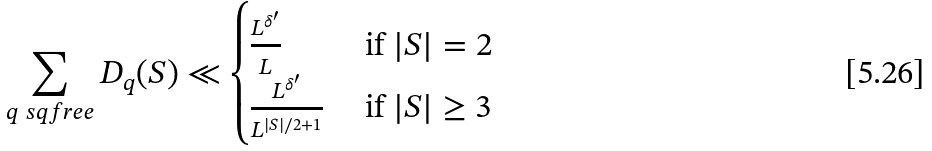<formula> <loc_0><loc_0><loc_500><loc_500>\sum _ { q \ s q f r e e } D _ { q } ( S ) \ll \begin{cases} \frac { L ^ { \delta ^ { \prime } } } { L } & \text { if } | S | = 2 \\ \frac { L ^ { \delta ^ { \prime } } } { L ^ { | S | / 2 + 1 } } & \text { if } | S | \geq 3 \end{cases}</formula> 